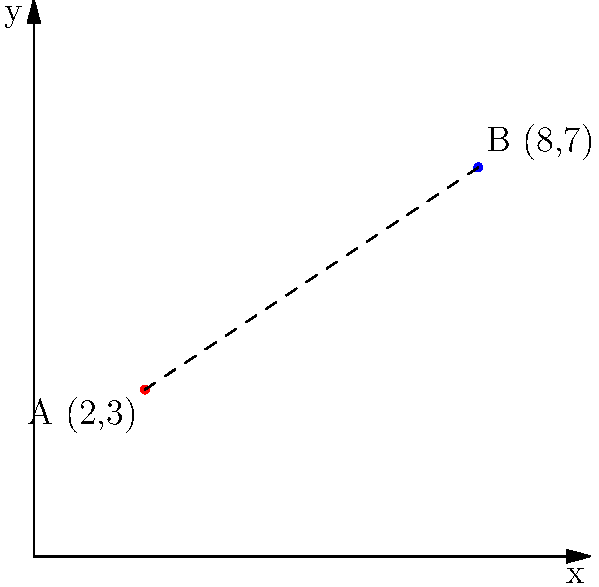Two mental health support centers, A and B, are located on a city map represented by a coordinate plane. Center A is at (2,3) and Center B is at (8,7). As a social worker, you need to determine the straight-line distance between these centers to assess resource allocation. Calculate the distance between points A and B using the distance formula. To find the distance between two points on a coordinate plane, we use the distance formula:

$$d = \sqrt{(x_2 - x_1)^2 + (y_2 - y_1)^2}$$

Where $(x_1, y_1)$ represents the coordinates of the first point and $(x_2, y_2)$ represents the coordinates of the second point.

Given:
- Point A: $(x_1, y_1) = (2, 3)$
- Point B: $(x_2, y_2) = (8, 7)$

Let's substitute these values into the formula:

$$d = \sqrt{(8 - 2)^2 + (7 - 3)^2}$$

Simplify:
$$d = \sqrt{6^2 + 4^2}$$

Calculate the squares:
$$d = \sqrt{36 + 16}$$

Add under the square root:
$$d = \sqrt{52}$$

Simplify the square root:
$$d = 2\sqrt{13}$$

Therefore, the distance between the two support centers is $2\sqrt{13}$ units.
Answer: $2\sqrt{13}$ units 